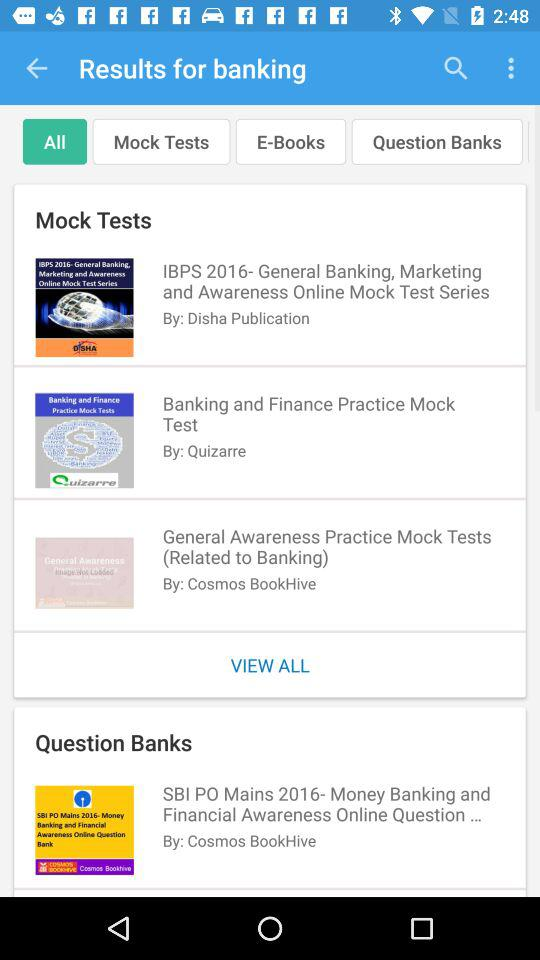Who is the author of the Banking and Finance Practice Mock Test? The author of the Banking and Finance Practice Mock Test is Quizarre. 